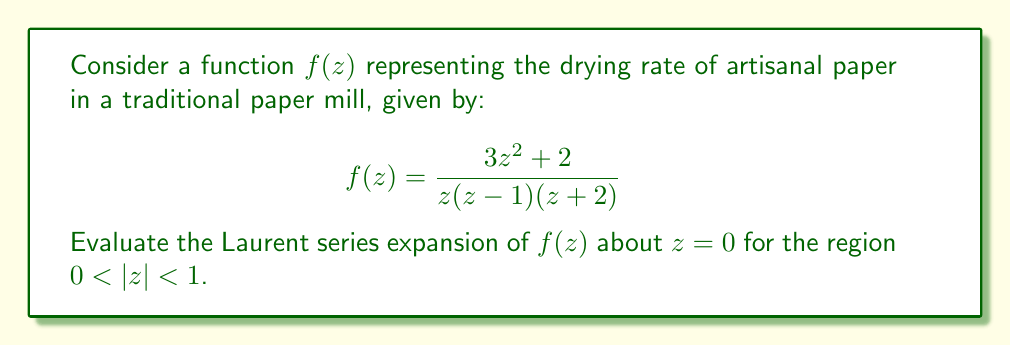What is the answer to this math problem? To find the Laurent series expansion of $f(z)$ about $z=0$ for $0 < |z| < 1$, we'll follow these steps:

1) First, we need to perform partial fraction decomposition on $f(z)$:

   $$f(z) = \frac{3z^2 + 2}{z(z-1)(z+2)} = \frac{A}{z} + \frac{B}{z-1} + \frac{C}{z+2}$$

2) Solving for A, B, and C:

   $$A(z-1)(z+2) + Bz(z+2) + Cz(z-1) = 3z^2 + 2$$

   Comparing coefficients and solving the system of equations, we get:
   $A = -1$, $B = 1$, $C = 3$

3) So, our function can be written as:

   $$f(z) = -\frac{1}{z} + \frac{1}{z-1} + \frac{3}{z+2}$$

4) Now, we need to expand each term:

   For $-\frac{1}{z}$, it's already in the correct form.

   For $\frac{1}{z-1}$, we can use the geometric series:
   $$\frac{1}{z-1} = -\frac{1}{1-z} = -(1 + z + z^2 + z^3 + ...)$$
   This is valid for $|z| < 1$, which fits our region.

   For $\frac{3}{z+2}$, we can factor out $\frac{1}{2}$ and use the geometric series again:
   $$\frac{3}{z+2} = \frac{3}{2} \cdot \frac{1}{1+\frac{z}{2}} = \frac{3}{2}(1 - \frac{z}{2} + \frac{z^2}{4} - \frac{z^3}{8} + ...)$$
   This is valid for $|z| < 2$, which includes our region.

5) Combining all terms:

   $$f(z) = -\frac{1}{z} - (1 + z + z^2 + z^3 + ...) + \frac{3}{2}(1 - \frac{z}{2} + \frac{z^2}{4} - \frac{z^3}{8} + ...)$$

6) Grouping terms by powers of z:

   $$f(z) = -\frac{1}{z} + (\frac{3}{2} - 1) + (-1 - \frac{3}{4})z + (-1 + \frac{3}{8})z^2 + (-1 - \frac{3}{16})z^3 + ...$$
Answer: The Laurent series expansion of $f(z)$ about $z=0$ for $0 < |z| < 1$ is:

$$f(z) = -\frac{1}{z} + \frac{1}{2} - \frac{7}{4}z - \frac{5}{8}z^2 - \frac{19}{16}z^3 + ...$$ 